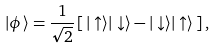<formula> <loc_0><loc_0><loc_500><loc_500>| \phi \rangle = \frac { 1 } { \sqrt { 2 } } \left [ \, | \uparrow \rangle | \downarrow \rangle - | \downarrow \rangle | \uparrow \rangle \, \right ] ,</formula> 